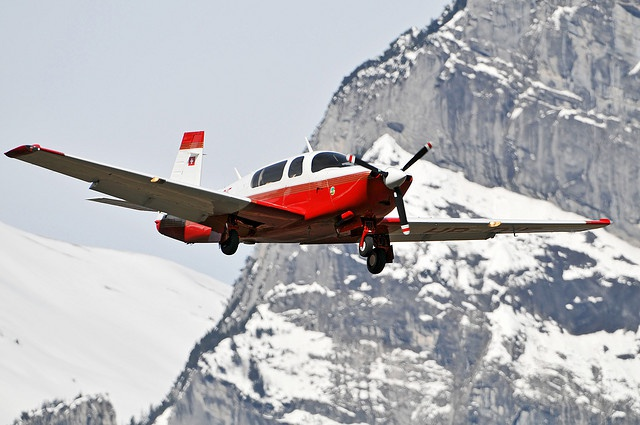Describe the objects in this image and their specific colors. I can see a airplane in lightgray, black, maroon, and white tones in this image. 